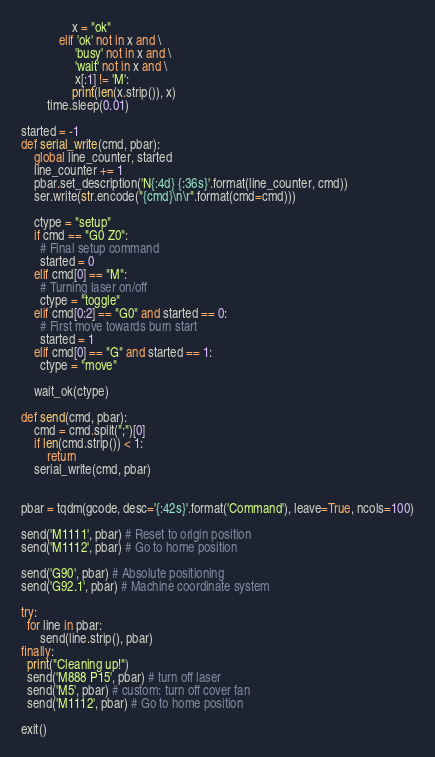Convert code to text. <code><loc_0><loc_0><loc_500><loc_500><_Python_>                x = "ok"
            elif 'ok' not in x and \
                 'busy' not in x and \
                 'wait' not in x and \
                 x[:1] != 'M':
                print(len(x.strip()), x)
        time.sleep(0.01)
    
started = -1
def serial_write(cmd, pbar):
    global line_counter, started
    line_counter += 1
    pbar.set_description('N{:4d} {:36s}'.format(line_counter, cmd))
    ser.write(str.encode("{cmd}\n\r".format(cmd=cmd)))

    ctype = "setup"
    if cmd == "G0 Z0":  
      # Final setup command
      started = 0
    elif cmd[0] == "M":
      # Turning laser on/off
      ctype = "toggle"
    elif cmd[0:2] == "G0" and started == 0:
      # First move towards burn start
      started = 1
    elif cmd[0] == "G" and started == 1:
      ctype = "move"  

    wait_ok(ctype)

def send(cmd, pbar):
    cmd = cmd.split(";")[0]
    if len(cmd.strip()) < 1:
        return
    serial_write(cmd, pbar)


pbar = tqdm(gcode, desc='{:42s}'.format('Command'), leave=True, ncols=100)
    
send('M1111', pbar) # Reset to origin position
send('M1112', pbar) # Go to home position

send('G90', pbar) # Absolute positioning
send('G92.1', pbar) # Machine coordinate system

try: 
  for line in pbar:
      send(line.strip(), pbar)
finally:
  print("Cleaning up!")
  send('M888 P15', pbar) # turn off laser
  send('M5', pbar) # custom: turn off cover fan
  send('M1112', pbar) # Go to home position

exit()
</code> 